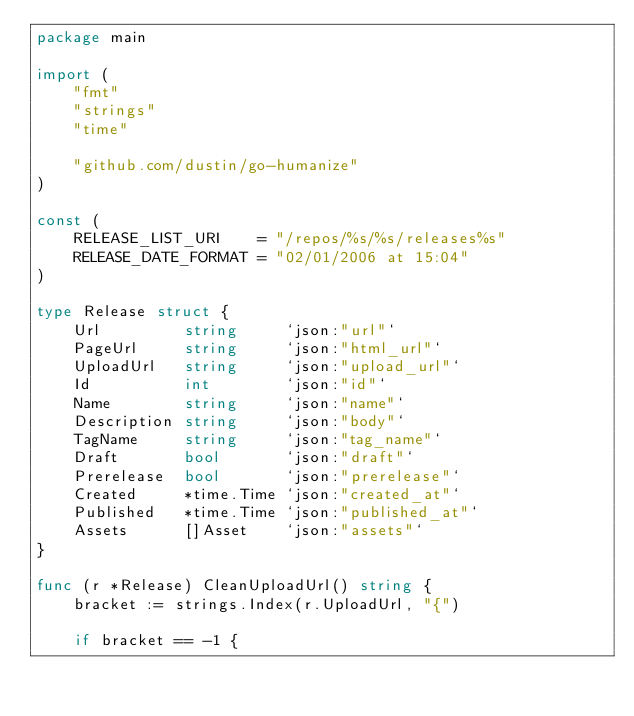<code> <loc_0><loc_0><loc_500><loc_500><_Go_>package main

import (
	"fmt"
	"strings"
	"time"

	"github.com/dustin/go-humanize"
)

const (
	RELEASE_LIST_URI    = "/repos/%s/%s/releases%s"
	RELEASE_DATE_FORMAT = "02/01/2006 at 15:04"
)

type Release struct {
	Url         string     `json:"url"`
	PageUrl     string     `json:"html_url"`
	UploadUrl   string     `json:"upload_url"`
	Id          int        `json:"id"`
	Name        string     `json:"name"`
	Description string     `json:"body"`
	TagName     string     `json:"tag_name"`
	Draft       bool       `json:"draft"`
	Prerelease  bool       `json:"prerelease"`
	Created     *time.Time `json:"created_at"`
	Published   *time.Time `json:"published_at"`
	Assets      []Asset    `json:"assets"`
}

func (r *Release) CleanUploadUrl() string {
	bracket := strings.Index(r.UploadUrl, "{")

	if bracket == -1 {</code> 